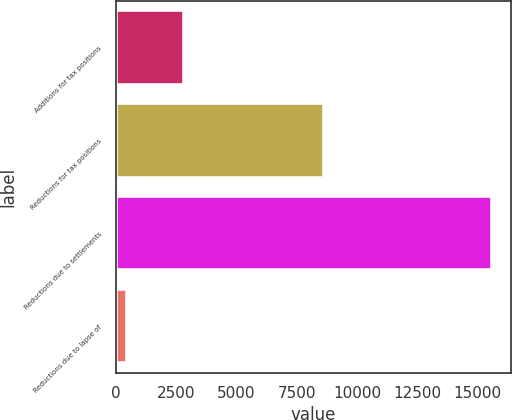Convert chart to OTSL. <chart><loc_0><loc_0><loc_500><loc_500><bar_chart><fcel>Additions for tax positions<fcel>Reductions for tax positions<fcel>Reductions due to settlements<fcel>Reductions due to lapse of<nl><fcel>2796<fcel>8645<fcel>15608<fcel>432<nl></chart> 